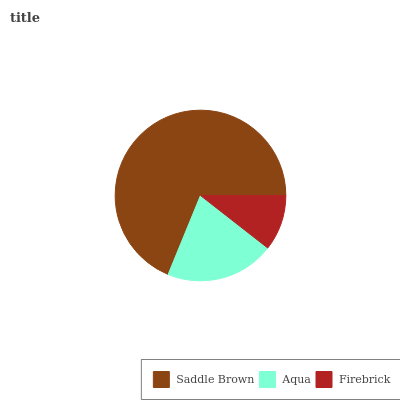Is Firebrick the minimum?
Answer yes or no. Yes. Is Saddle Brown the maximum?
Answer yes or no. Yes. Is Aqua the minimum?
Answer yes or no. No. Is Aqua the maximum?
Answer yes or no. No. Is Saddle Brown greater than Aqua?
Answer yes or no. Yes. Is Aqua less than Saddle Brown?
Answer yes or no. Yes. Is Aqua greater than Saddle Brown?
Answer yes or no. No. Is Saddle Brown less than Aqua?
Answer yes or no. No. Is Aqua the high median?
Answer yes or no. Yes. Is Aqua the low median?
Answer yes or no. Yes. Is Saddle Brown the high median?
Answer yes or no. No. Is Saddle Brown the low median?
Answer yes or no. No. 